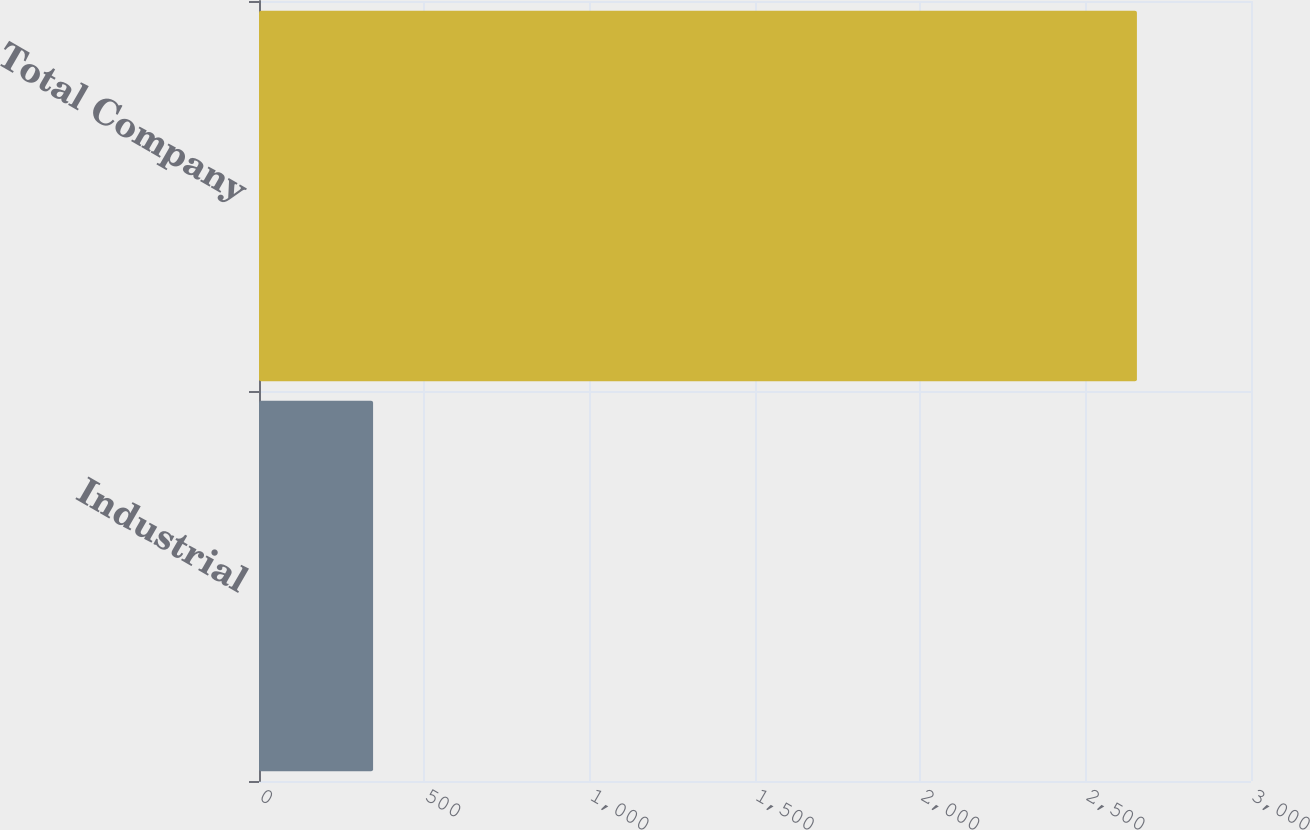<chart> <loc_0><loc_0><loc_500><loc_500><bar_chart><fcel>Industrial<fcel>Total Company<nl><fcel>345<fcel>2655<nl></chart> 